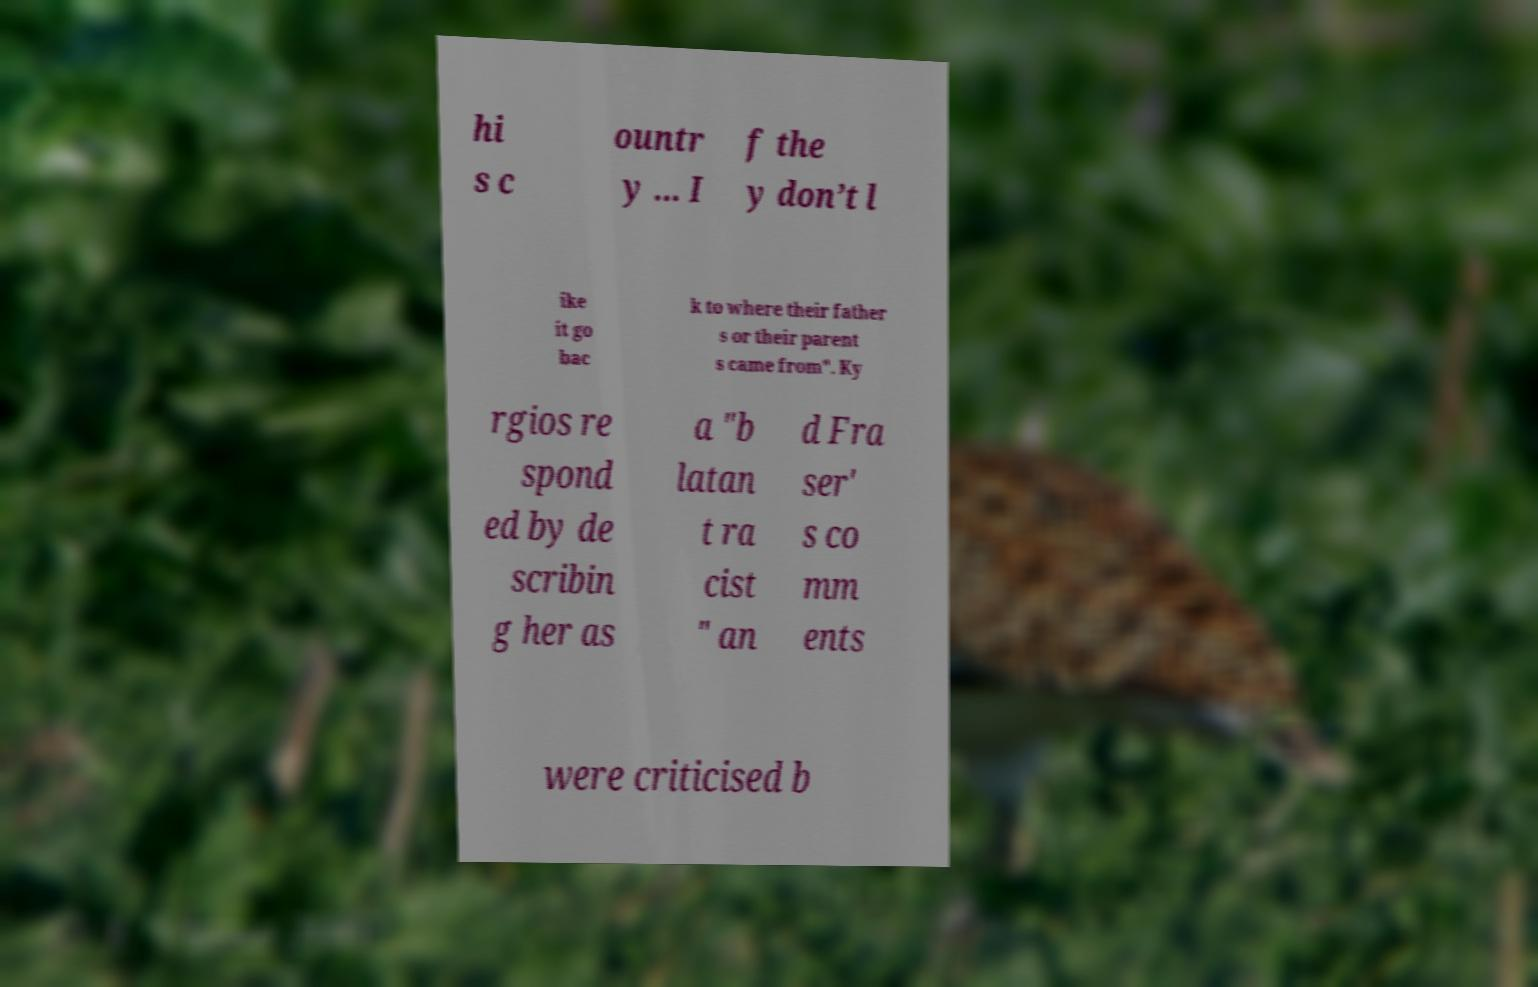I need the written content from this picture converted into text. Can you do that? hi s c ountr y ... I f the y don’t l ike it go bac k to where their father s or their parent s came from". Ky rgios re spond ed by de scribin g her as a "b latan t ra cist " an d Fra ser' s co mm ents were criticised b 